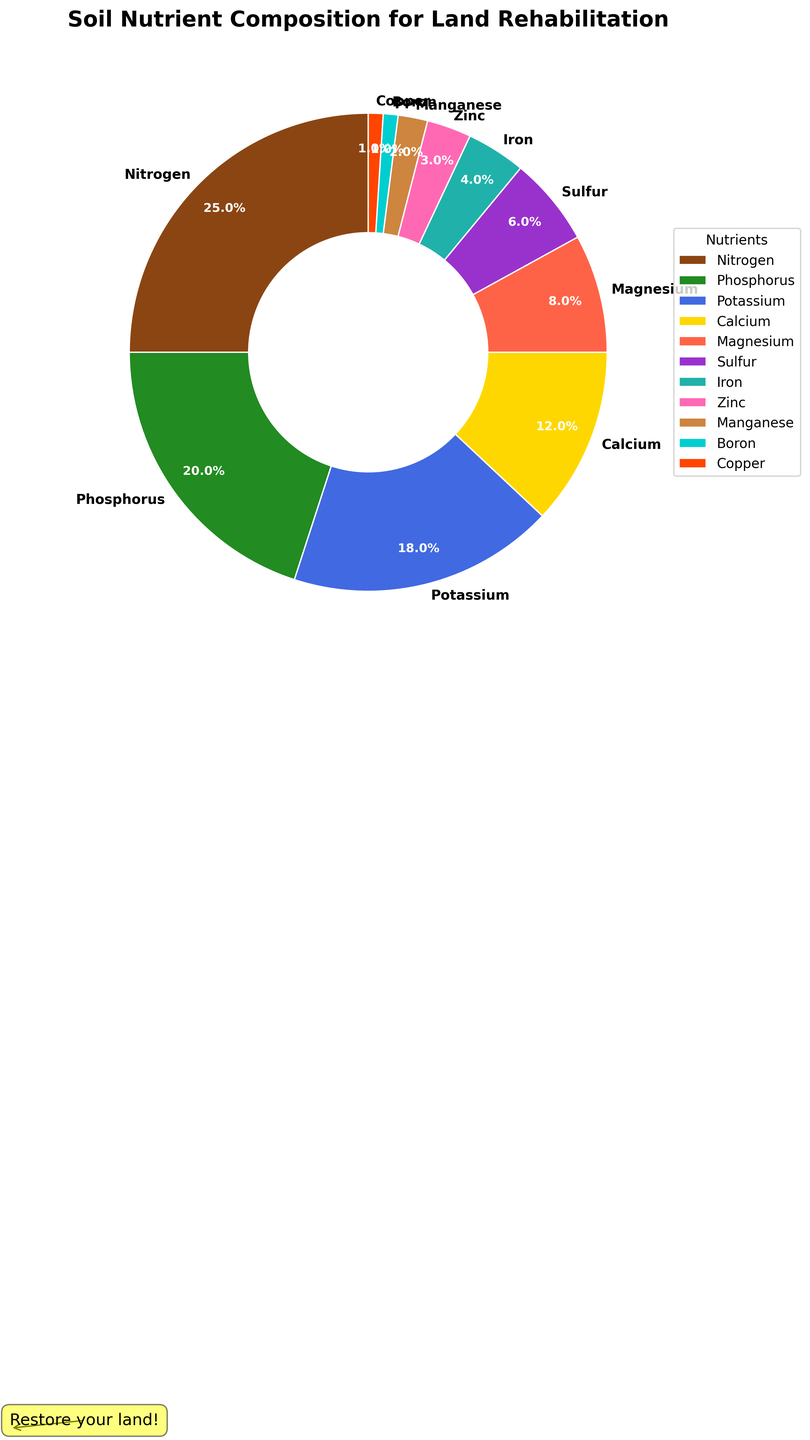What is the nutrient with the highest percentage? The nutrient with the highest percentage is the one with the largest slice in the pie chart. By looking at the chart, we see that nitrogen has the largest share.
Answer: Nitrogen Which nutrient has a greater percentage, Phosphorus or Potassium? To determine which nutrient has a greater percentage, compare the respective slices for Phosphorus and Potassium. Phosphorus has a larger slice (20%) compared to Potassium (18%).
Answer: Phosphorus What is the combined percentage of Calcium and Magnesium? Add the percentages of Calcium (12%) and Magnesium (8%). The combined percentage is 12% + 8% = 20%.
Answer: 20% Which nutrients have portions less than 5%? Nutrients with portions less than 5% are those with smaller slices in the chart. These nutrients are Iron (4%), Zinc (3%), Manganese (2%), Boron (1%), and Copper (1%).
Answer: Iron, Zinc, Manganese, Boron, Copper How does the share of Nitrogen compare to the total of Sulfur and Iron? Compare the percentage of Nitrogen (25%) to the sum of Sulfur (6%) and Iron (4%). The total for Sulfur and Iron is 6% + 4% = 10%. Nitrogen's share (25%) is greater than the total for Sulfur and Iron (10%).
Answer: Nitrogen is greater Which color represents Potassium on the pie chart? Identify the color associated with Potassium by looking at the chart. Potassium is represented by the light blue color.
Answer: Light blue If you combine the percentages of Boron and Copper, what is their combined proportion to the total percentage of Magnesium? First, add the percentages of Boron (1%) and Copper (1%), which is 1% + 1% = 2%. Then, compare this to Magnesium's percentage, which is 8%. Boron and Copper's combined proportion is 2% of the total, while Magnesium alone is 8%.
Answer: 2% What is the median value of the percentage data presented in the pie chart? To find the median value, arrange the percentages in ascending order: [1, 1, 2, 3, 4, 6, 8, 12, 18, 20, 25]. The median value is the middle number, which is the sixth value in this ordered list. Therefore, the median value is 6%.
Answer: 6% 